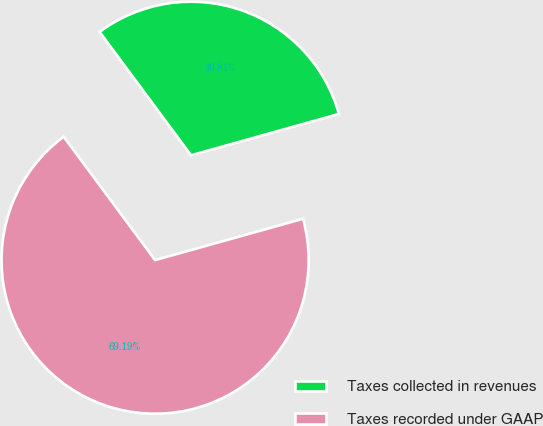<chart> <loc_0><loc_0><loc_500><loc_500><pie_chart><fcel>Taxes collected in revenues<fcel>Taxes recorded under GAAP<nl><fcel>30.81%<fcel>69.19%<nl></chart> 